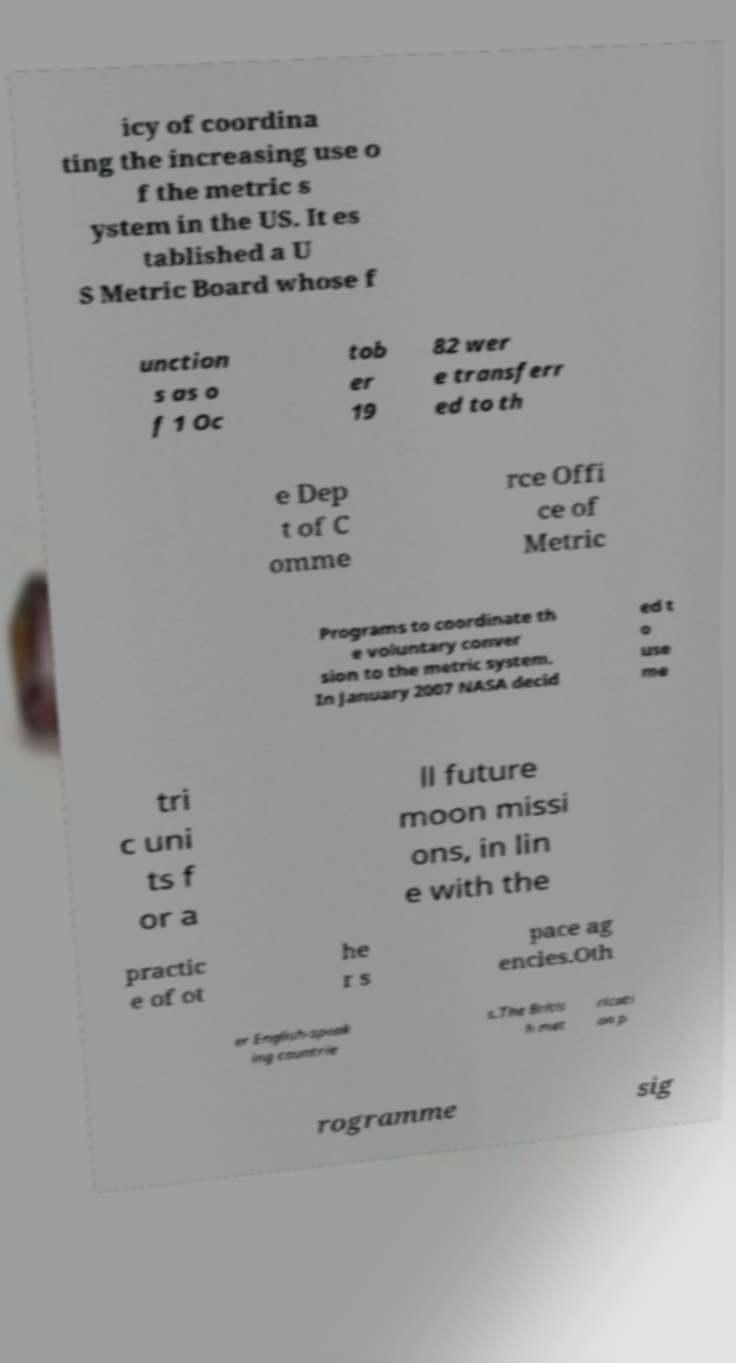Could you extract and type out the text from this image? icy of coordina ting the increasing use o f the metric s ystem in the US. It es tablished a U S Metric Board whose f unction s as o f 1 Oc tob er 19 82 wer e transferr ed to th e Dep t of C omme rce Offi ce of Metric Programs to coordinate th e voluntary conver sion to the metric system. In January 2007 NASA decid ed t o use me tri c uni ts f or a ll future moon missi ons, in lin e with the practic e of ot he r s pace ag encies.Oth er English-speak ing countrie s.The Britis h met ricati on p rogramme sig 